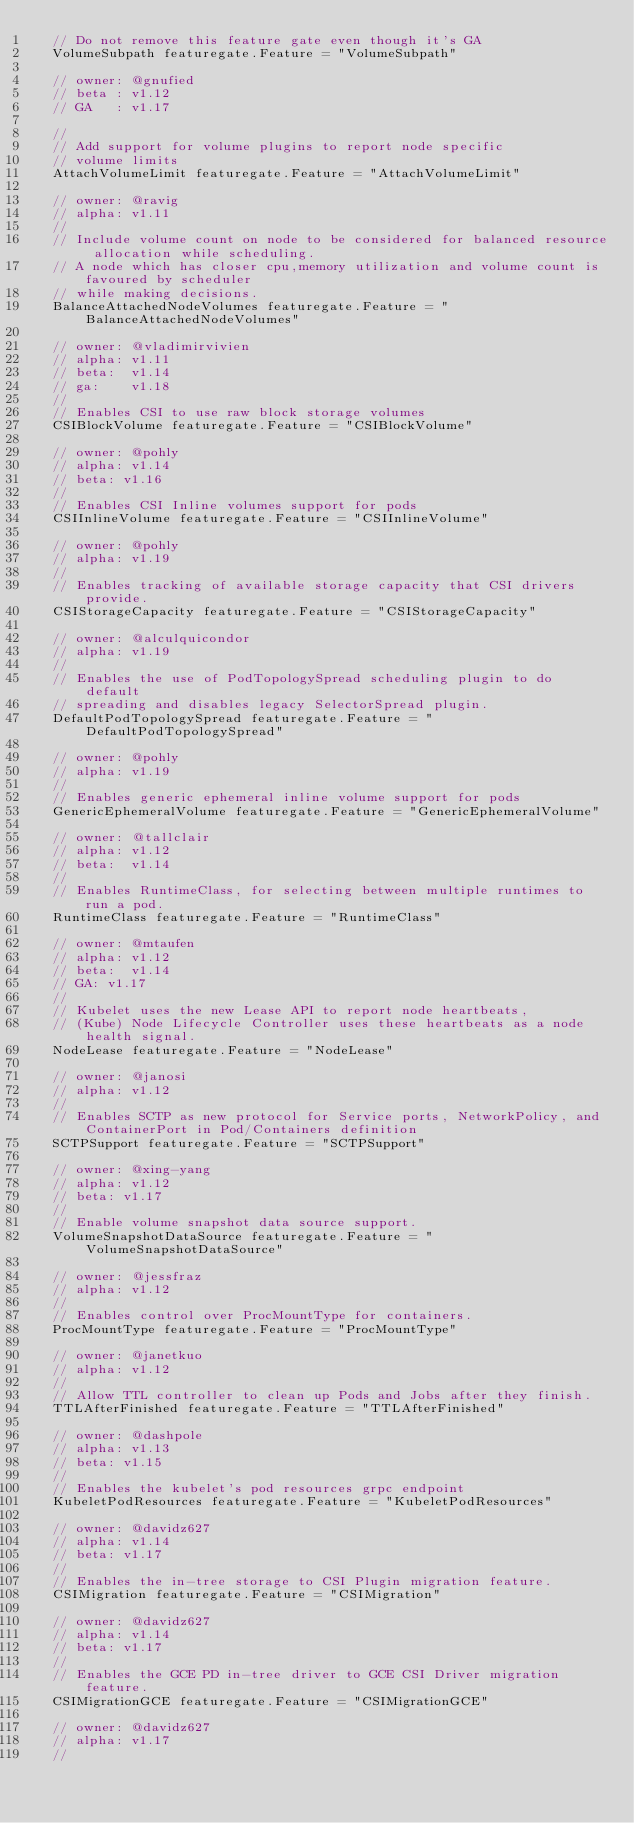<code> <loc_0><loc_0><loc_500><loc_500><_Go_>	// Do not remove this feature gate even though it's GA
	VolumeSubpath featuregate.Feature = "VolumeSubpath"

	// owner: @gnufied
	// beta : v1.12
	// GA   : v1.17

	//
	// Add support for volume plugins to report node specific
	// volume limits
	AttachVolumeLimit featuregate.Feature = "AttachVolumeLimit"

	// owner: @ravig
	// alpha: v1.11
	//
	// Include volume count on node to be considered for balanced resource allocation while scheduling.
	// A node which has closer cpu,memory utilization and volume count is favoured by scheduler
	// while making decisions.
	BalanceAttachedNodeVolumes featuregate.Feature = "BalanceAttachedNodeVolumes"

	// owner: @vladimirvivien
	// alpha: v1.11
	// beta:  v1.14
	// ga: 	  v1.18
	//
	// Enables CSI to use raw block storage volumes
	CSIBlockVolume featuregate.Feature = "CSIBlockVolume"

	// owner: @pohly
	// alpha: v1.14
	// beta: v1.16
	//
	// Enables CSI Inline volumes support for pods
	CSIInlineVolume featuregate.Feature = "CSIInlineVolume"

	// owner: @pohly
	// alpha: v1.19
	//
	// Enables tracking of available storage capacity that CSI drivers provide.
	CSIStorageCapacity featuregate.Feature = "CSIStorageCapacity"

	// owner: @alculquicondor
	// alpha: v1.19
	//
	// Enables the use of PodTopologySpread scheduling plugin to do default
	// spreading and disables legacy SelectorSpread plugin.
	DefaultPodTopologySpread featuregate.Feature = "DefaultPodTopologySpread"

	// owner: @pohly
	// alpha: v1.19
	//
	// Enables generic ephemeral inline volume support for pods
	GenericEphemeralVolume featuregate.Feature = "GenericEphemeralVolume"

	// owner: @tallclair
	// alpha: v1.12
	// beta:  v1.14
	//
	// Enables RuntimeClass, for selecting between multiple runtimes to run a pod.
	RuntimeClass featuregate.Feature = "RuntimeClass"

	// owner: @mtaufen
	// alpha: v1.12
	// beta:  v1.14
	// GA: v1.17
	//
	// Kubelet uses the new Lease API to report node heartbeats,
	// (Kube) Node Lifecycle Controller uses these heartbeats as a node health signal.
	NodeLease featuregate.Feature = "NodeLease"

	// owner: @janosi
	// alpha: v1.12
	//
	// Enables SCTP as new protocol for Service ports, NetworkPolicy, and ContainerPort in Pod/Containers definition
	SCTPSupport featuregate.Feature = "SCTPSupport"

	// owner: @xing-yang
	// alpha: v1.12
	// beta: v1.17
	//
	// Enable volume snapshot data source support.
	VolumeSnapshotDataSource featuregate.Feature = "VolumeSnapshotDataSource"

	// owner: @jessfraz
	// alpha: v1.12
	//
	// Enables control over ProcMountType for containers.
	ProcMountType featuregate.Feature = "ProcMountType"

	// owner: @janetkuo
	// alpha: v1.12
	//
	// Allow TTL controller to clean up Pods and Jobs after they finish.
	TTLAfterFinished featuregate.Feature = "TTLAfterFinished"

	// owner: @dashpole
	// alpha: v1.13
	// beta: v1.15
	//
	// Enables the kubelet's pod resources grpc endpoint
	KubeletPodResources featuregate.Feature = "KubeletPodResources"

	// owner: @davidz627
	// alpha: v1.14
	// beta: v1.17
	//
	// Enables the in-tree storage to CSI Plugin migration feature.
	CSIMigration featuregate.Feature = "CSIMigration"

	// owner: @davidz627
	// alpha: v1.14
	// beta: v1.17
	//
	// Enables the GCE PD in-tree driver to GCE CSI Driver migration feature.
	CSIMigrationGCE featuregate.Feature = "CSIMigrationGCE"

	// owner: @davidz627
	// alpha: v1.17
	//</code> 